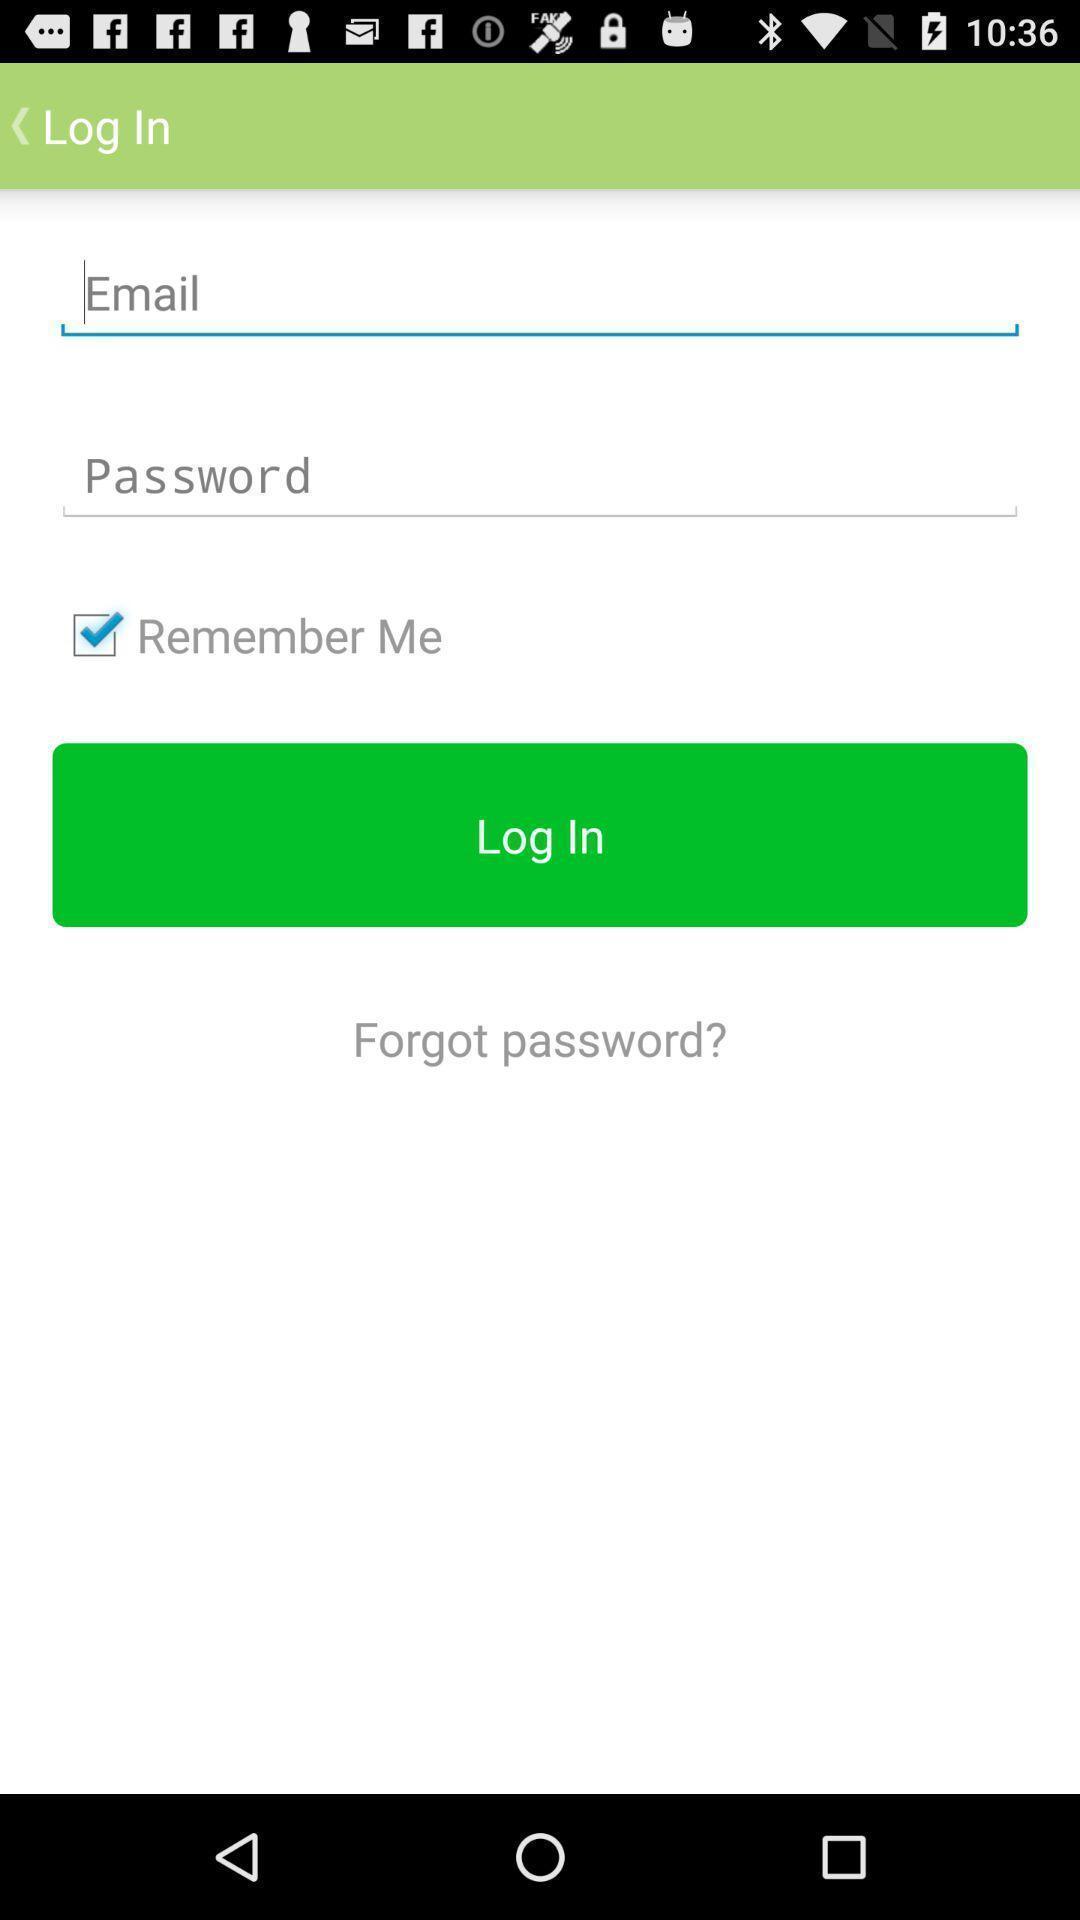What details can you identify in this image? Page asking for user login details. 